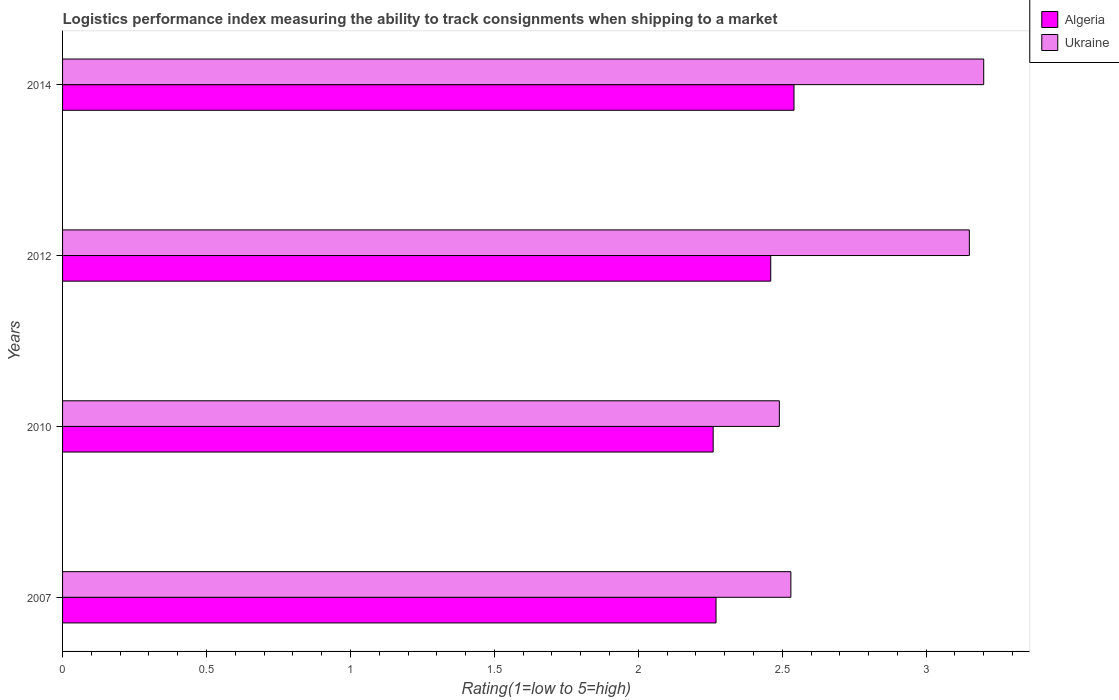How many different coloured bars are there?
Offer a very short reply. 2. How many groups of bars are there?
Offer a very short reply. 4. Are the number of bars on each tick of the Y-axis equal?
Ensure brevity in your answer.  Yes. What is the label of the 4th group of bars from the top?
Your answer should be compact. 2007. In how many cases, is the number of bars for a given year not equal to the number of legend labels?
Your answer should be very brief. 0. What is the Logistic performance index in Ukraine in 2007?
Ensure brevity in your answer.  2.53. Across all years, what is the maximum Logistic performance index in Algeria?
Provide a succinct answer. 2.54. Across all years, what is the minimum Logistic performance index in Algeria?
Offer a terse response. 2.26. What is the total Logistic performance index in Algeria in the graph?
Your response must be concise. 9.53. What is the difference between the Logistic performance index in Algeria in 2012 and that in 2014?
Your response must be concise. -0.08. What is the difference between the Logistic performance index in Algeria in 2010 and the Logistic performance index in Ukraine in 2014?
Provide a short and direct response. -0.94. What is the average Logistic performance index in Ukraine per year?
Provide a short and direct response. 2.84. In the year 2007, what is the difference between the Logistic performance index in Ukraine and Logistic performance index in Algeria?
Your answer should be very brief. 0.26. What is the ratio of the Logistic performance index in Ukraine in 2012 to that in 2014?
Provide a succinct answer. 0.98. Is the difference between the Logistic performance index in Ukraine in 2007 and 2010 greater than the difference between the Logistic performance index in Algeria in 2007 and 2010?
Your response must be concise. Yes. What is the difference between the highest and the second highest Logistic performance index in Ukraine?
Your response must be concise. 0.05. What is the difference between the highest and the lowest Logistic performance index in Ukraine?
Make the answer very short. 0.71. In how many years, is the Logistic performance index in Algeria greater than the average Logistic performance index in Algeria taken over all years?
Your response must be concise. 2. What does the 2nd bar from the top in 2012 represents?
Ensure brevity in your answer.  Algeria. What does the 2nd bar from the bottom in 2007 represents?
Your response must be concise. Ukraine. Does the graph contain grids?
Give a very brief answer. No. How are the legend labels stacked?
Provide a succinct answer. Vertical. What is the title of the graph?
Your response must be concise. Logistics performance index measuring the ability to track consignments when shipping to a market. Does "Sint Maarten (Dutch part)" appear as one of the legend labels in the graph?
Offer a very short reply. No. What is the label or title of the X-axis?
Offer a terse response. Rating(1=low to 5=high). What is the label or title of the Y-axis?
Provide a succinct answer. Years. What is the Rating(1=low to 5=high) of Algeria in 2007?
Keep it short and to the point. 2.27. What is the Rating(1=low to 5=high) in Ukraine in 2007?
Give a very brief answer. 2.53. What is the Rating(1=low to 5=high) in Algeria in 2010?
Provide a short and direct response. 2.26. What is the Rating(1=low to 5=high) in Ukraine in 2010?
Provide a short and direct response. 2.49. What is the Rating(1=low to 5=high) in Algeria in 2012?
Provide a short and direct response. 2.46. What is the Rating(1=low to 5=high) of Ukraine in 2012?
Ensure brevity in your answer.  3.15. What is the Rating(1=low to 5=high) of Algeria in 2014?
Your answer should be very brief. 2.54. What is the Rating(1=low to 5=high) in Ukraine in 2014?
Ensure brevity in your answer.  3.2. Across all years, what is the maximum Rating(1=low to 5=high) of Algeria?
Ensure brevity in your answer.  2.54. Across all years, what is the maximum Rating(1=low to 5=high) in Ukraine?
Provide a short and direct response. 3.2. Across all years, what is the minimum Rating(1=low to 5=high) of Algeria?
Offer a terse response. 2.26. Across all years, what is the minimum Rating(1=low to 5=high) in Ukraine?
Offer a very short reply. 2.49. What is the total Rating(1=low to 5=high) in Algeria in the graph?
Ensure brevity in your answer.  9.53. What is the total Rating(1=low to 5=high) of Ukraine in the graph?
Keep it short and to the point. 11.37. What is the difference between the Rating(1=low to 5=high) of Ukraine in 2007 and that in 2010?
Your response must be concise. 0.04. What is the difference between the Rating(1=low to 5=high) of Algeria in 2007 and that in 2012?
Your answer should be compact. -0.19. What is the difference between the Rating(1=low to 5=high) of Ukraine in 2007 and that in 2012?
Give a very brief answer. -0.62. What is the difference between the Rating(1=low to 5=high) in Algeria in 2007 and that in 2014?
Offer a terse response. -0.27. What is the difference between the Rating(1=low to 5=high) in Ukraine in 2007 and that in 2014?
Your answer should be compact. -0.67. What is the difference between the Rating(1=low to 5=high) of Ukraine in 2010 and that in 2012?
Your response must be concise. -0.66. What is the difference between the Rating(1=low to 5=high) in Algeria in 2010 and that in 2014?
Your response must be concise. -0.28. What is the difference between the Rating(1=low to 5=high) in Ukraine in 2010 and that in 2014?
Give a very brief answer. -0.71. What is the difference between the Rating(1=low to 5=high) in Algeria in 2012 and that in 2014?
Give a very brief answer. -0.08. What is the difference between the Rating(1=low to 5=high) in Ukraine in 2012 and that in 2014?
Your answer should be very brief. -0.05. What is the difference between the Rating(1=low to 5=high) in Algeria in 2007 and the Rating(1=low to 5=high) in Ukraine in 2010?
Your answer should be very brief. -0.22. What is the difference between the Rating(1=low to 5=high) in Algeria in 2007 and the Rating(1=low to 5=high) in Ukraine in 2012?
Your answer should be compact. -0.88. What is the difference between the Rating(1=low to 5=high) in Algeria in 2007 and the Rating(1=low to 5=high) in Ukraine in 2014?
Offer a terse response. -0.93. What is the difference between the Rating(1=low to 5=high) in Algeria in 2010 and the Rating(1=low to 5=high) in Ukraine in 2012?
Offer a very short reply. -0.89. What is the difference between the Rating(1=low to 5=high) of Algeria in 2010 and the Rating(1=low to 5=high) of Ukraine in 2014?
Give a very brief answer. -0.94. What is the difference between the Rating(1=low to 5=high) in Algeria in 2012 and the Rating(1=low to 5=high) in Ukraine in 2014?
Provide a short and direct response. -0.74. What is the average Rating(1=low to 5=high) of Algeria per year?
Provide a succinct answer. 2.38. What is the average Rating(1=low to 5=high) of Ukraine per year?
Make the answer very short. 2.84. In the year 2007, what is the difference between the Rating(1=low to 5=high) in Algeria and Rating(1=low to 5=high) in Ukraine?
Give a very brief answer. -0.26. In the year 2010, what is the difference between the Rating(1=low to 5=high) of Algeria and Rating(1=low to 5=high) of Ukraine?
Offer a terse response. -0.23. In the year 2012, what is the difference between the Rating(1=low to 5=high) of Algeria and Rating(1=low to 5=high) of Ukraine?
Ensure brevity in your answer.  -0.69. In the year 2014, what is the difference between the Rating(1=low to 5=high) of Algeria and Rating(1=low to 5=high) of Ukraine?
Your answer should be very brief. -0.66. What is the ratio of the Rating(1=low to 5=high) in Ukraine in 2007 to that in 2010?
Ensure brevity in your answer.  1.02. What is the ratio of the Rating(1=low to 5=high) in Algeria in 2007 to that in 2012?
Keep it short and to the point. 0.92. What is the ratio of the Rating(1=low to 5=high) in Ukraine in 2007 to that in 2012?
Make the answer very short. 0.8. What is the ratio of the Rating(1=low to 5=high) in Algeria in 2007 to that in 2014?
Offer a very short reply. 0.89. What is the ratio of the Rating(1=low to 5=high) of Ukraine in 2007 to that in 2014?
Offer a very short reply. 0.79. What is the ratio of the Rating(1=low to 5=high) in Algeria in 2010 to that in 2012?
Ensure brevity in your answer.  0.92. What is the ratio of the Rating(1=low to 5=high) of Ukraine in 2010 to that in 2012?
Keep it short and to the point. 0.79. What is the ratio of the Rating(1=low to 5=high) in Algeria in 2010 to that in 2014?
Provide a succinct answer. 0.89. What is the ratio of the Rating(1=low to 5=high) in Ukraine in 2010 to that in 2014?
Ensure brevity in your answer.  0.78. What is the ratio of the Rating(1=low to 5=high) in Algeria in 2012 to that in 2014?
Your answer should be compact. 0.97. What is the ratio of the Rating(1=low to 5=high) in Ukraine in 2012 to that in 2014?
Provide a short and direct response. 0.98. What is the difference between the highest and the second highest Rating(1=low to 5=high) of Algeria?
Give a very brief answer. 0.08. What is the difference between the highest and the second highest Rating(1=low to 5=high) in Ukraine?
Offer a very short reply. 0.05. What is the difference between the highest and the lowest Rating(1=low to 5=high) of Algeria?
Provide a short and direct response. 0.28. What is the difference between the highest and the lowest Rating(1=low to 5=high) in Ukraine?
Provide a short and direct response. 0.71. 